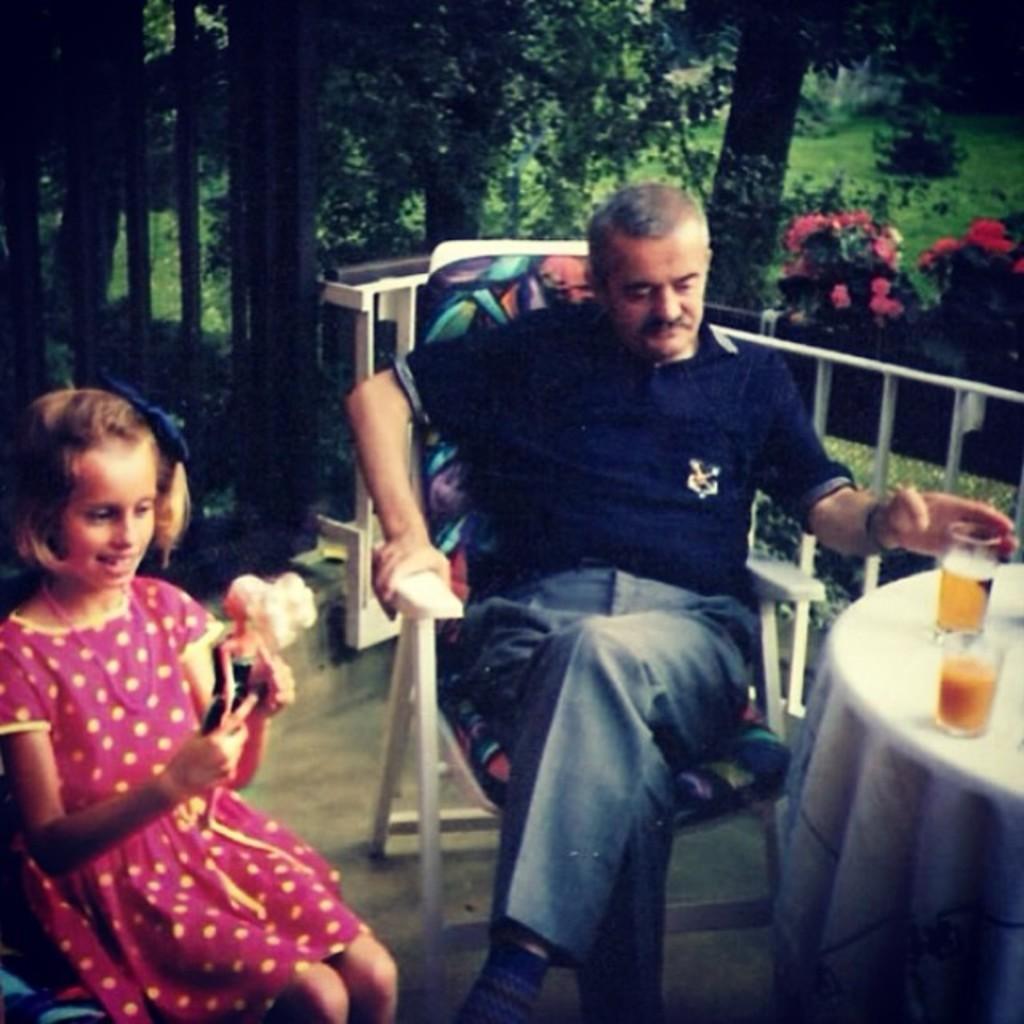Can you describe this image briefly? This picture shows a man and a girl seated on the chairs and we see two glasses on the table and few trees around. 